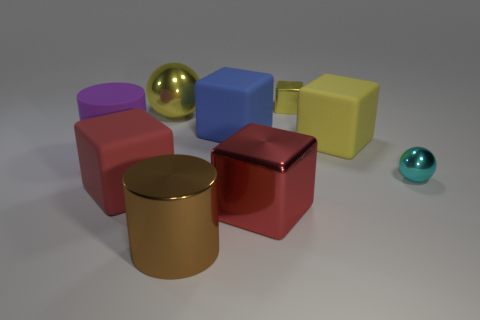What number of objects are either tiny metal cylinders or things on the left side of the big yellow block?
Keep it short and to the point. 7. There is a purple thing; does it have the same size as the rubber block that is in front of the purple rubber cylinder?
Your answer should be very brief. Yes. How many cubes are either red rubber objects or red shiny things?
Ensure brevity in your answer.  2. What number of things are both left of the small cube and in front of the big yellow metal sphere?
Keep it short and to the point. 5. How many other objects are the same color as the tiny cube?
Your answer should be very brief. 2. What shape is the large red thing right of the big red rubber thing?
Your response must be concise. Cube. Do the small sphere and the small yellow block have the same material?
Provide a short and direct response. Yes. Is there any other thing that is the same size as the cyan shiny thing?
Keep it short and to the point. Yes. What number of blue rubber things are to the right of the brown cylinder?
Offer a terse response. 1. What shape is the large yellow object to the left of the cylinder that is right of the big matte cylinder?
Make the answer very short. Sphere. 